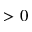Convert formula to latex. <formula><loc_0><loc_0><loc_500><loc_500>> 0</formula> 